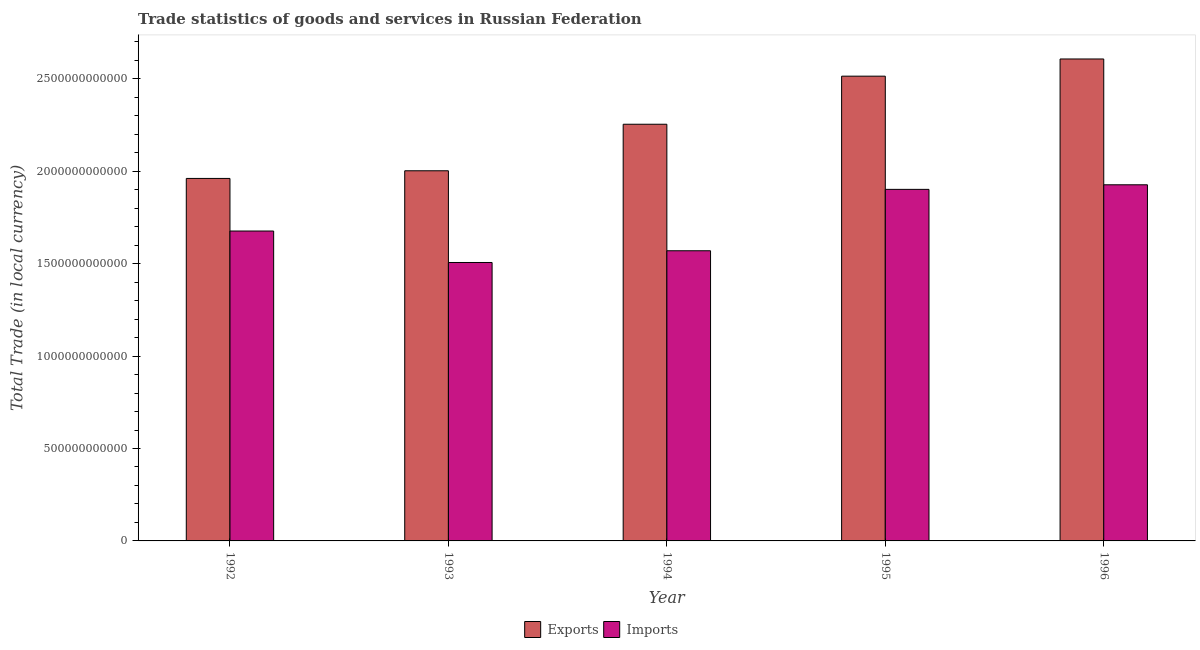How many different coloured bars are there?
Provide a short and direct response. 2. How many groups of bars are there?
Make the answer very short. 5. Are the number of bars on each tick of the X-axis equal?
Your response must be concise. Yes. How many bars are there on the 3rd tick from the left?
Keep it short and to the point. 2. What is the label of the 5th group of bars from the left?
Ensure brevity in your answer.  1996. In how many cases, is the number of bars for a given year not equal to the number of legend labels?
Your answer should be compact. 0. What is the export of goods and services in 1994?
Ensure brevity in your answer.  2.25e+12. Across all years, what is the maximum export of goods and services?
Give a very brief answer. 2.61e+12. Across all years, what is the minimum export of goods and services?
Your response must be concise. 1.96e+12. In which year was the imports of goods and services maximum?
Your answer should be compact. 1996. In which year was the imports of goods and services minimum?
Ensure brevity in your answer.  1993. What is the total export of goods and services in the graph?
Offer a terse response. 1.13e+13. What is the difference between the export of goods and services in 1993 and that in 1996?
Give a very brief answer. -6.05e+11. What is the difference between the imports of goods and services in 1994 and the export of goods and services in 1993?
Offer a terse response. 6.35e+1. What is the average imports of goods and services per year?
Give a very brief answer. 1.72e+12. What is the ratio of the export of goods and services in 1994 to that in 1995?
Give a very brief answer. 0.9. What is the difference between the highest and the second highest export of goods and services?
Provide a short and direct response. 9.30e+1. What is the difference between the highest and the lowest imports of goods and services?
Your answer should be compact. 4.20e+11. In how many years, is the imports of goods and services greater than the average imports of goods and services taken over all years?
Provide a succinct answer. 2. What does the 2nd bar from the left in 1995 represents?
Your response must be concise. Imports. What does the 2nd bar from the right in 1994 represents?
Ensure brevity in your answer.  Exports. How many bars are there?
Offer a very short reply. 10. What is the difference between two consecutive major ticks on the Y-axis?
Ensure brevity in your answer.  5.00e+11. Are the values on the major ticks of Y-axis written in scientific E-notation?
Offer a very short reply. No. Does the graph contain grids?
Keep it short and to the point. No. Where does the legend appear in the graph?
Provide a short and direct response. Bottom center. What is the title of the graph?
Give a very brief answer. Trade statistics of goods and services in Russian Federation. Does "Crop" appear as one of the legend labels in the graph?
Your answer should be very brief. No. What is the label or title of the X-axis?
Provide a succinct answer. Year. What is the label or title of the Y-axis?
Give a very brief answer. Total Trade (in local currency). What is the Total Trade (in local currency) in Exports in 1992?
Ensure brevity in your answer.  1.96e+12. What is the Total Trade (in local currency) in Imports in 1992?
Ensure brevity in your answer.  1.68e+12. What is the Total Trade (in local currency) of Exports in 1993?
Offer a very short reply. 2.00e+12. What is the Total Trade (in local currency) in Imports in 1993?
Your answer should be very brief. 1.51e+12. What is the Total Trade (in local currency) in Exports in 1994?
Make the answer very short. 2.25e+12. What is the Total Trade (in local currency) of Imports in 1994?
Provide a short and direct response. 1.57e+12. What is the Total Trade (in local currency) of Exports in 1995?
Provide a succinct answer. 2.51e+12. What is the Total Trade (in local currency) of Imports in 1995?
Ensure brevity in your answer.  1.90e+12. What is the Total Trade (in local currency) in Exports in 1996?
Make the answer very short. 2.61e+12. What is the Total Trade (in local currency) of Imports in 1996?
Make the answer very short. 1.93e+12. Across all years, what is the maximum Total Trade (in local currency) in Exports?
Provide a short and direct response. 2.61e+12. Across all years, what is the maximum Total Trade (in local currency) of Imports?
Make the answer very short. 1.93e+12. Across all years, what is the minimum Total Trade (in local currency) in Exports?
Ensure brevity in your answer.  1.96e+12. Across all years, what is the minimum Total Trade (in local currency) in Imports?
Your answer should be very brief. 1.51e+12. What is the total Total Trade (in local currency) of Exports in the graph?
Provide a succinct answer. 1.13e+13. What is the total Total Trade (in local currency) of Imports in the graph?
Ensure brevity in your answer.  8.58e+12. What is the difference between the Total Trade (in local currency) in Exports in 1992 and that in 1993?
Provide a succinct answer. -4.14e+1. What is the difference between the Total Trade (in local currency) in Imports in 1992 and that in 1993?
Your answer should be compact. 1.70e+11. What is the difference between the Total Trade (in local currency) in Exports in 1992 and that in 1994?
Make the answer very short. -2.93e+11. What is the difference between the Total Trade (in local currency) of Imports in 1992 and that in 1994?
Your response must be concise. 1.07e+11. What is the difference between the Total Trade (in local currency) in Exports in 1992 and that in 1995?
Your response must be concise. -5.53e+11. What is the difference between the Total Trade (in local currency) of Imports in 1992 and that in 1995?
Make the answer very short. -2.25e+11. What is the difference between the Total Trade (in local currency) in Exports in 1992 and that in 1996?
Make the answer very short. -6.46e+11. What is the difference between the Total Trade (in local currency) in Imports in 1992 and that in 1996?
Keep it short and to the point. -2.50e+11. What is the difference between the Total Trade (in local currency) of Exports in 1993 and that in 1994?
Provide a short and direct response. -2.52e+11. What is the difference between the Total Trade (in local currency) of Imports in 1993 and that in 1994?
Provide a short and direct response. -6.35e+1. What is the difference between the Total Trade (in local currency) in Exports in 1993 and that in 1995?
Ensure brevity in your answer.  -5.12e+11. What is the difference between the Total Trade (in local currency) in Imports in 1993 and that in 1995?
Make the answer very short. -3.96e+11. What is the difference between the Total Trade (in local currency) of Exports in 1993 and that in 1996?
Offer a terse response. -6.05e+11. What is the difference between the Total Trade (in local currency) in Imports in 1993 and that in 1996?
Ensure brevity in your answer.  -4.20e+11. What is the difference between the Total Trade (in local currency) of Exports in 1994 and that in 1995?
Give a very brief answer. -2.60e+11. What is the difference between the Total Trade (in local currency) in Imports in 1994 and that in 1995?
Provide a succinct answer. -3.32e+11. What is the difference between the Total Trade (in local currency) in Exports in 1994 and that in 1996?
Provide a succinct answer. -3.53e+11. What is the difference between the Total Trade (in local currency) in Imports in 1994 and that in 1996?
Offer a terse response. -3.57e+11. What is the difference between the Total Trade (in local currency) of Exports in 1995 and that in 1996?
Provide a succinct answer. -9.30e+1. What is the difference between the Total Trade (in local currency) of Imports in 1995 and that in 1996?
Ensure brevity in your answer.  -2.47e+1. What is the difference between the Total Trade (in local currency) of Exports in 1992 and the Total Trade (in local currency) of Imports in 1993?
Offer a very short reply. 4.55e+11. What is the difference between the Total Trade (in local currency) in Exports in 1992 and the Total Trade (in local currency) in Imports in 1994?
Give a very brief answer. 3.91e+11. What is the difference between the Total Trade (in local currency) of Exports in 1992 and the Total Trade (in local currency) of Imports in 1995?
Offer a terse response. 5.91e+1. What is the difference between the Total Trade (in local currency) of Exports in 1992 and the Total Trade (in local currency) of Imports in 1996?
Your answer should be very brief. 3.44e+1. What is the difference between the Total Trade (in local currency) in Exports in 1993 and the Total Trade (in local currency) in Imports in 1994?
Make the answer very short. 4.33e+11. What is the difference between the Total Trade (in local currency) of Exports in 1993 and the Total Trade (in local currency) of Imports in 1995?
Your answer should be very brief. 1.01e+11. What is the difference between the Total Trade (in local currency) in Exports in 1993 and the Total Trade (in local currency) in Imports in 1996?
Your answer should be very brief. 7.59e+1. What is the difference between the Total Trade (in local currency) of Exports in 1994 and the Total Trade (in local currency) of Imports in 1995?
Keep it short and to the point. 3.52e+11. What is the difference between the Total Trade (in local currency) in Exports in 1994 and the Total Trade (in local currency) in Imports in 1996?
Offer a very short reply. 3.28e+11. What is the difference between the Total Trade (in local currency) in Exports in 1995 and the Total Trade (in local currency) in Imports in 1996?
Give a very brief answer. 5.88e+11. What is the average Total Trade (in local currency) in Exports per year?
Make the answer very short. 2.27e+12. What is the average Total Trade (in local currency) in Imports per year?
Provide a short and direct response. 1.72e+12. In the year 1992, what is the difference between the Total Trade (in local currency) of Exports and Total Trade (in local currency) of Imports?
Your answer should be compact. 2.84e+11. In the year 1993, what is the difference between the Total Trade (in local currency) of Exports and Total Trade (in local currency) of Imports?
Ensure brevity in your answer.  4.96e+11. In the year 1994, what is the difference between the Total Trade (in local currency) in Exports and Total Trade (in local currency) in Imports?
Make the answer very short. 6.84e+11. In the year 1995, what is the difference between the Total Trade (in local currency) of Exports and Total Trade (in local currency) of Imports?
Give a very brief answer. 6.12e+11. In the year 1996, what is the difference between the Total Trade (in local currency) of Exports and Total Trade (in local currency) of Imports?
Your response must be concise. 6.81e+11. What is the ratio of the Total Trade (in local currency) of Exports in 1992 to that in 1993?
Your answer should be compact. 0.98. What is the ratio of the Total Trade (in local currency) in Imports in 1992 to that in 1993?
Ensure brevity in your answer.  1.11. What is the ratio of the Total Trade (in local currency) of Exports in 1992 to that in 1994?
Provide a succinct answer. 0.87. What is the ratio of the Total Trade (in local currency) in Imports in 1992 to that in 1994?
Make the answer very short. 1.07. What is the ratio of the Total Trade (in local currency) in Exports in 1992 to that in 1995?
Make the answer very short. 0.78. What is the ratio of the Total Trade (in local currency) of Imports in 1992 to that in 1995?
Your answer should be compact. 0.88. What is the ratio of the Total Trade (in local currency) of Exports in 1992 to that in 1996?
Ensure brevity in your answer.  0.75. What is the ratio of the Total Trade (in local currency) in Imports in 1992 to that in 1996?
Keep it short and to the point. 0.87. What is the ratio of the Total Trade (in local currency) in Exports in 1993 to that in 1994?
Offer a terse response. 0.89. What is the ratio of the Total Trade (in local currency) of Imports in 1993 to that in 1994?
Your answer should be compact. 0.96. What is the ratio of the Total Trade (in local currency) of Exports in 1993 to that in 1995?
Your answer should be compact. 0.8. What is the ratio of the Total Trade (in local currency) of Imports in 1993 to that in 1995?
Your response must be concise. 0.79. What is the ratio of the Total Trade (in local currency) of Exports in 1993 to that in 1996?
Offer a terse response. 0.77. What is the ratio of the Total Trade (in local currency) in Imports in 1993 to that in 1996?
Your answer should be compact. 0.78. What is the ratio of the Total Trade (in local currency) in Exports in 1994 to that in 1995?
Provide a short and direct response. 0.9. What is the ratio of the Total Trade (in local currency) in Imports in 1994 to that in 1995?
Give a very brief answer. 0.83. What is the ratio of the Total Trade (in local currency) in Exports in 1994 to that in 1996?
Your answer should be very brief. 0.86. What is the ratio of the Total Trade (in local currency) in Imports in 1994 to that in 1996?
Your answer should be compact. 0.81. What is the ratio of the Total Trade (in local currency) in Exports in 1995 to that in 1996?
Your response must be concise. 0.96. What is the ratio of the Total Trade (in local currency) in Imports in 1995 to that in 1996?
Give a very brief answer. 0.99. What is the difference between the highest and the second highest Total Trade (in local currency) in Exports?
Ensure brevity in your answer.  9.30e+1. What is the difference between the highest and the second highest Total Trade (in local currency) in Imports?
Keep it short and to the point. 2.47e+1. What is the difference between the highest and the lowest Total Trade (in local currency) in Exports?
Give a very brief answer. 6.46e+11. What is the difference between the highest and the lowest Total Trade (in local currency) of Imports?
Make the answer very short. 4.20e+11. 